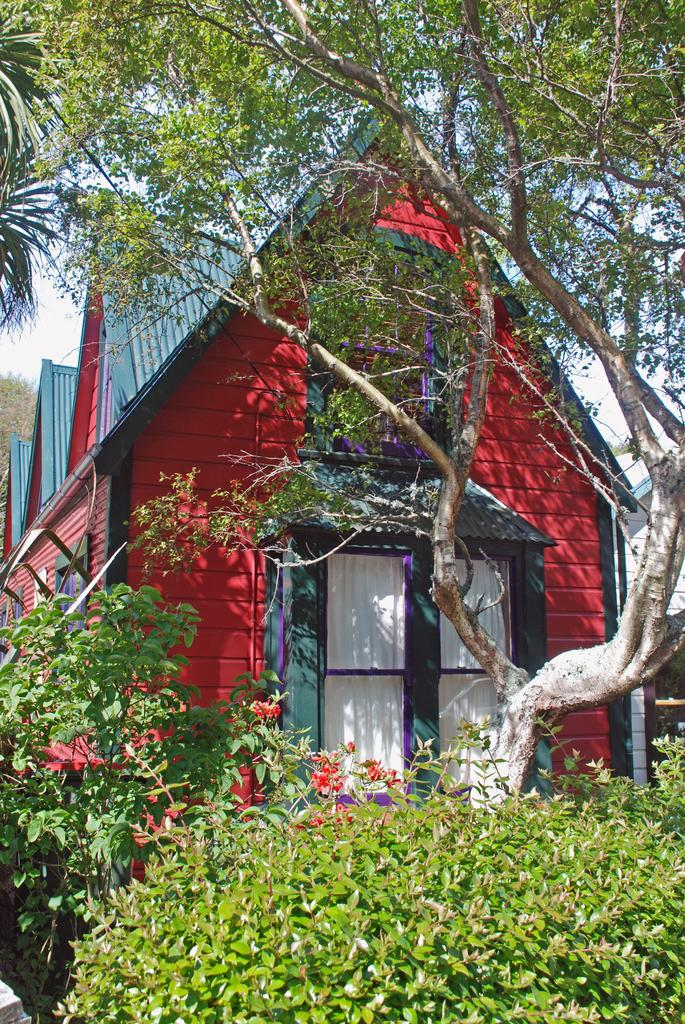What is located at the bottom of the picture? There are plants at the bottom of the picture. What is behind the plants in the image? There is a tree behind the plants. What can be seen behind the tree in the image? There are red color buildings with blue color roofs behind the tree. How many knives are hanging from the branches of the tree in the image? There are no knives present in the image; it features plants, a tree, and buildings. Can you see any lizards crawling on the red buildings in the image? There are no lizards visible in the image; it only shows plants, a tree, and buildings. 